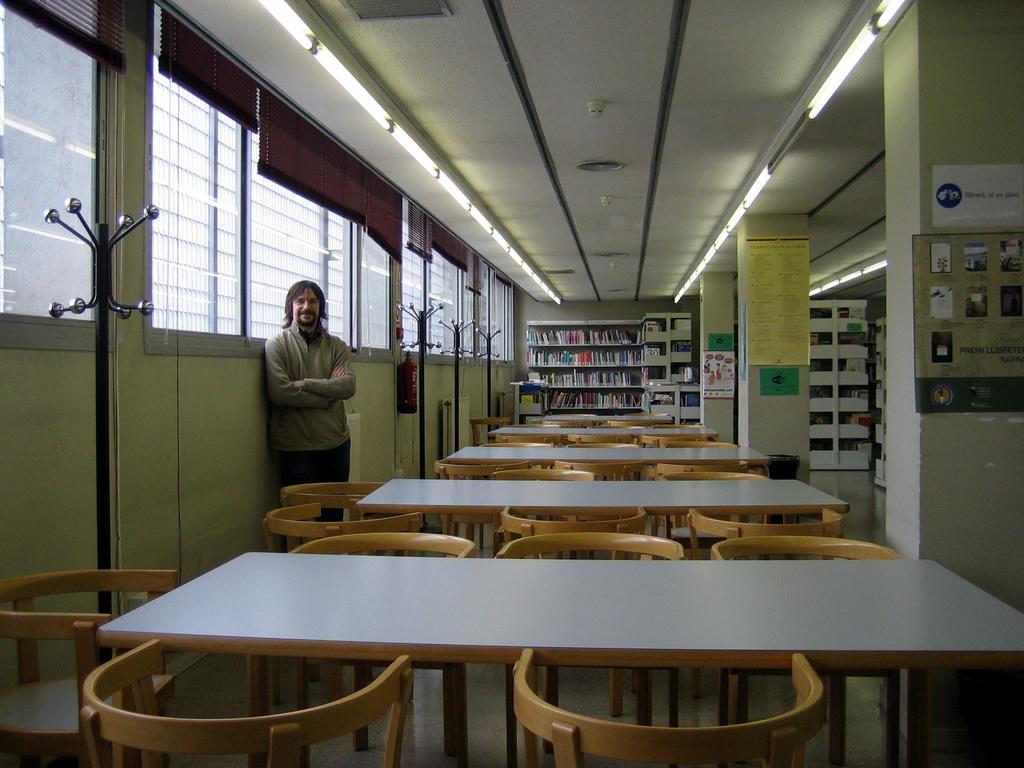Can you describe this image briefly? In this image we can see a man standing and smiling. We can also see the tables, chairs, pillars, posters and also the racks with the books. We can also see some black color stands, fire extinguisher, windows with the windows mats and at the top we can see the ceiling with the lights. 